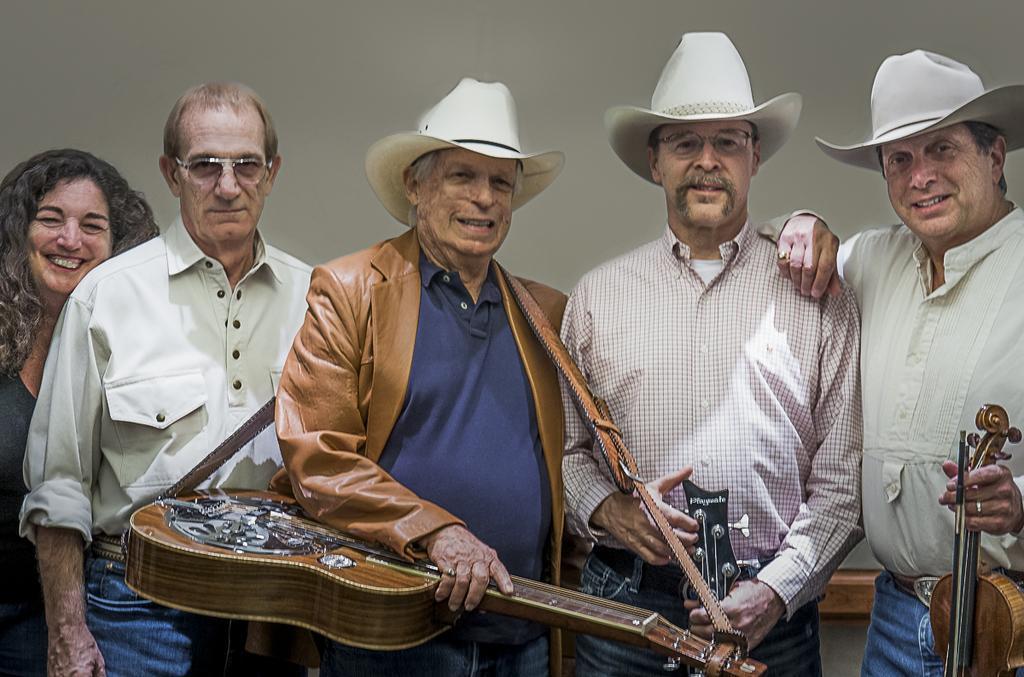In one or two sentences, can you explain what this image depicts? In this image there are a group of persons who are standing and smiling and on the right side there are three men who are standing and they are wearing hats and also they are holding guitars. On the background there is a wall. 